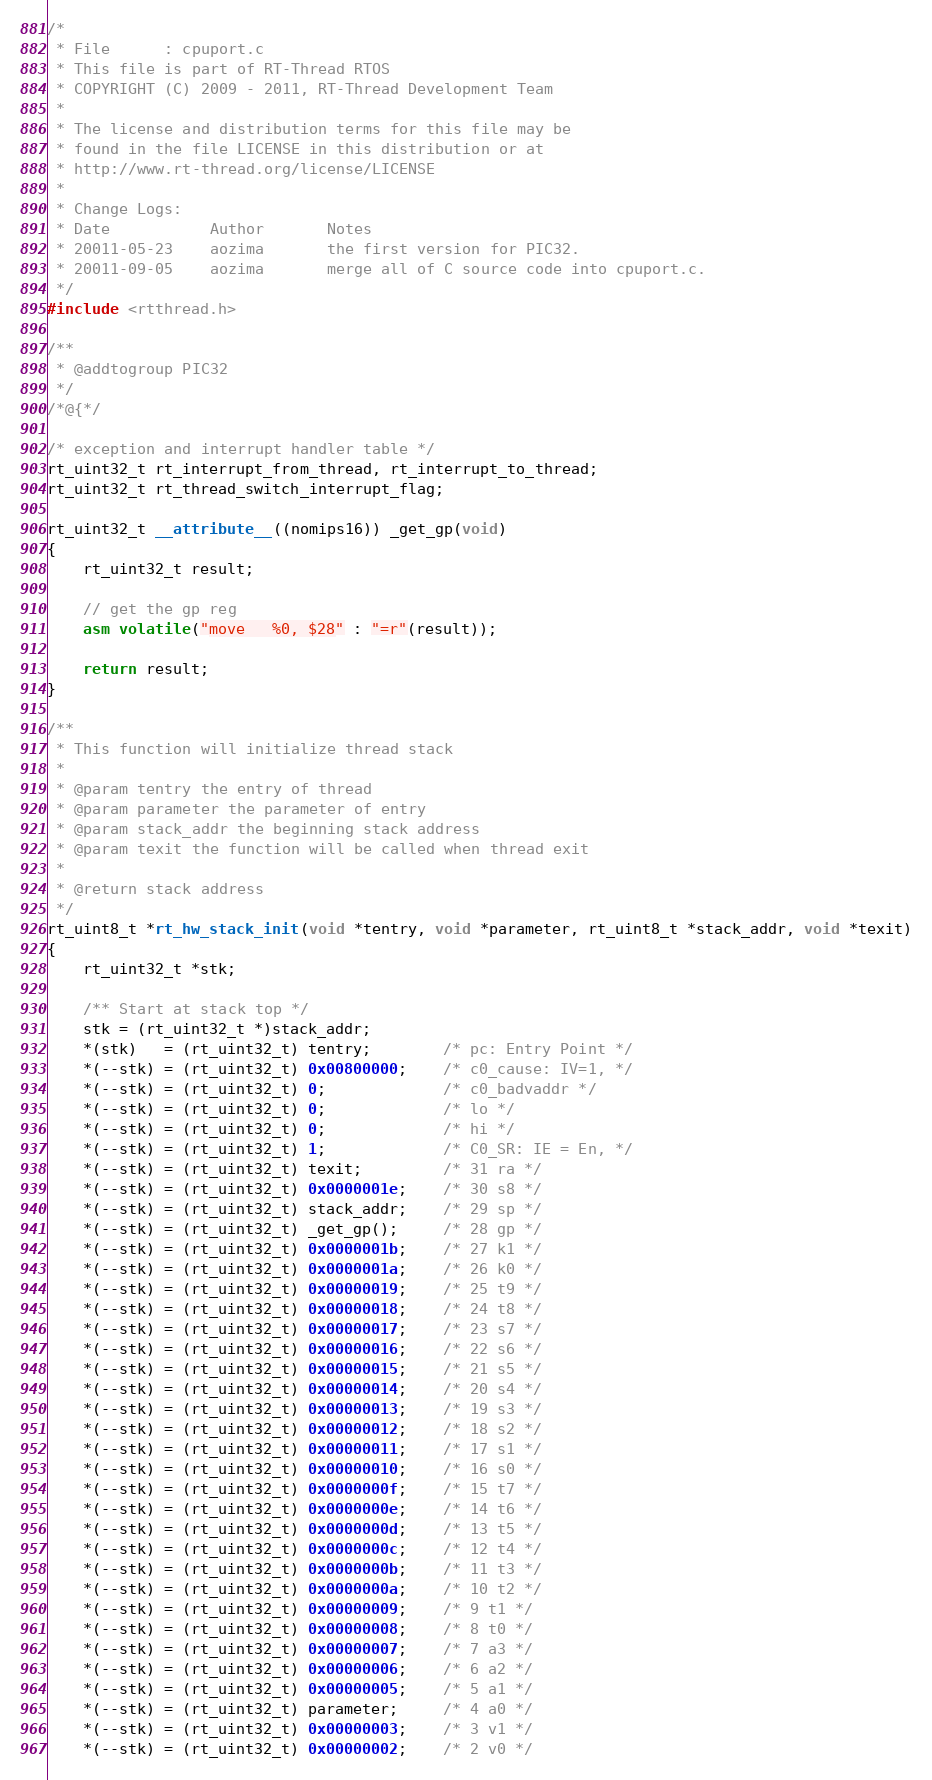Convert code to text. <code><loc_0><loc_0><loc_500><loc_500><_C_>/*
 * File      : cpuport.c
 * This file is part of RT-Thread RTOS
 * COPYRIGHT (C) 2009 - 2011, RT-Thread Development Team
 *
 * The license and distribution terms for this file may be
 * found in the file LICENSE in this distribution or at
 * http://www.rt-thread.org/license/LICENSE
 *
 * Change Logs:
 * Date           Author       Notes
 * 20011-05-23    aozima       the first version for PIC32.
 * 20011-09-05    aozima       merge all of C source code into cpuport.c.
 */
#include <rtthread.h>

/**
 * @addtogroup PIC32
 */
/*@{*/

/* exception and interrupt handler table */
rt_uint32_t rt_interrupt_from_thread, rt_interrupt_to_thread;
rt_uint32_t rt_thread_switch_interrupt_flag;

rt_uint32_t __attribute__((nomips16)) _get_gp(void)
{
    rt_uint32_t result;

    // get the gp reg
    asm volatile("move   %0, $28" : "=r"(result));

    return result;
}

/**
 * This function will initialize thread stack
 *
 * @param tentry the entry of thread
 * @param parameter the parameter of entry
 * @param stack_addr the beginning stack address
 * @param texit the function will be called when thread exit
 *
 * @return stack address
 */
rt_uint8_t *rt_hw_stack_init(void *tentry, void *parameter, rt_uint8_t *stack_addr, void *texit)
{
    rt_uint32_t *stk;

    /** Start at stack top */
    stk = (rt_uint32_t *)stack_addr;
    *(stk)   = (rt_uint32_t) tentry;        /* pc: Entry Point */
    *(--stk) = (rt_uint32_t) 0x00800000;    /* c0_cause: IV=1, */
    *(--stk) = (rt_uint32_t) 0;             /* c0_badvaddr */
    *(--stk) = (rt_uint32_t) 0;             /* lo */
    *(--stk) = (rt_uint32_t) 0;             /* hi */
    *(--stk) = (rt_uint32_t) 1;             /* C0_SR: IE = En, */
    *(--stk) = (rt_uint32_t) texit;         /* 31 ra */
    *(--stk) = (rt_uint32_t) 0x0000001e;    /* 30 s8 */
    *(--stk) = (rt_uint32_t) stack_addr;    /* 29 sp */
    *(--stk) = (rt_uint32_t) _get_gp();     /* 28 gp */
    *(--stk) = (rt_uint32_t) 0x0000001b;    /* 27 k1 */
    *(--stk) = (rt_uint32_t) 0x0000001a;    /* 26 k0 */
    *(--stk) = (rt_uint32_t) 0x00000019;    /* 25 t9 */
    *(--stk) = (rt_uint32_t) 0x00000018;    /* 24 t8 */
    *(--stk) = (rt_uint32_t) 0x00000017;    /* 23 s7 */
    *(--stk) = (rt_uint32_t) 0x00000016;    /* 22 s6 */
    *(--stk) = (rt_uint32_t) 0x00000015;    /* 21 s5 */
    *(--stk) = (rt_uint32_t) 0x00000014;    /* 20 s4 */
    *(--stk) = (rt_uint32_t) 0x00000013;    /* 19 s3 */
    *(--stk) = (rt_uint32_t) 0x00000012;    /* 18 s2 */
    *(--stk) = (rt_uint32_t) 0x00000011;    /* 17 s1 */
    *(--stk) = (rt_uint32_t) 0x00000010;    /* 16 s0 */
    *(--stk) = (rt_uint32_t) 0x0000000f;    /* 15 t7 */
    *(--stk) = (rt_uint32_t) 0x0000000e;    /* 14 t6 */
    *(--stk) = (rt_uint32_t) 0x0000000d;    /* 13 t5 */
    *(--stk) = (rt_uint32_t) 0x0000000c;    /* 12 t4 */
    *(--stk) = (rt_uint32_t) 0x0000000b;    /* 11 t3 */
    *(--stk) = (rt_uint32_t) 0x0000000a;    /* 10 t2 */
    *(--stk) = (rt_uint32_t) 0x00000009;    /* 9 t1 */
    *(--stk) = (rt_uint32_t) 0x00000008;    /* 8 t0 */
    *(--stk) = (rt_uint32_t) 0x00000007;    /* 7 a3 */
    *(--stk) = (rt_uint32_t) 0x00000006;    /* 6 a2 */
    *(--stk) = (rt_uint32_t) 0x00000005;    /* 5 a1 */
    *(--stk) = (rt_uint32_t) parameter;     /* 4 a0 */
    *(--stk) = (rt_uint32_t) 0x00000003;    /* 3 v1 */
    *(--stk) = (rt_uint32_t) 0x00000002;    /* 2 v0 */</code> 